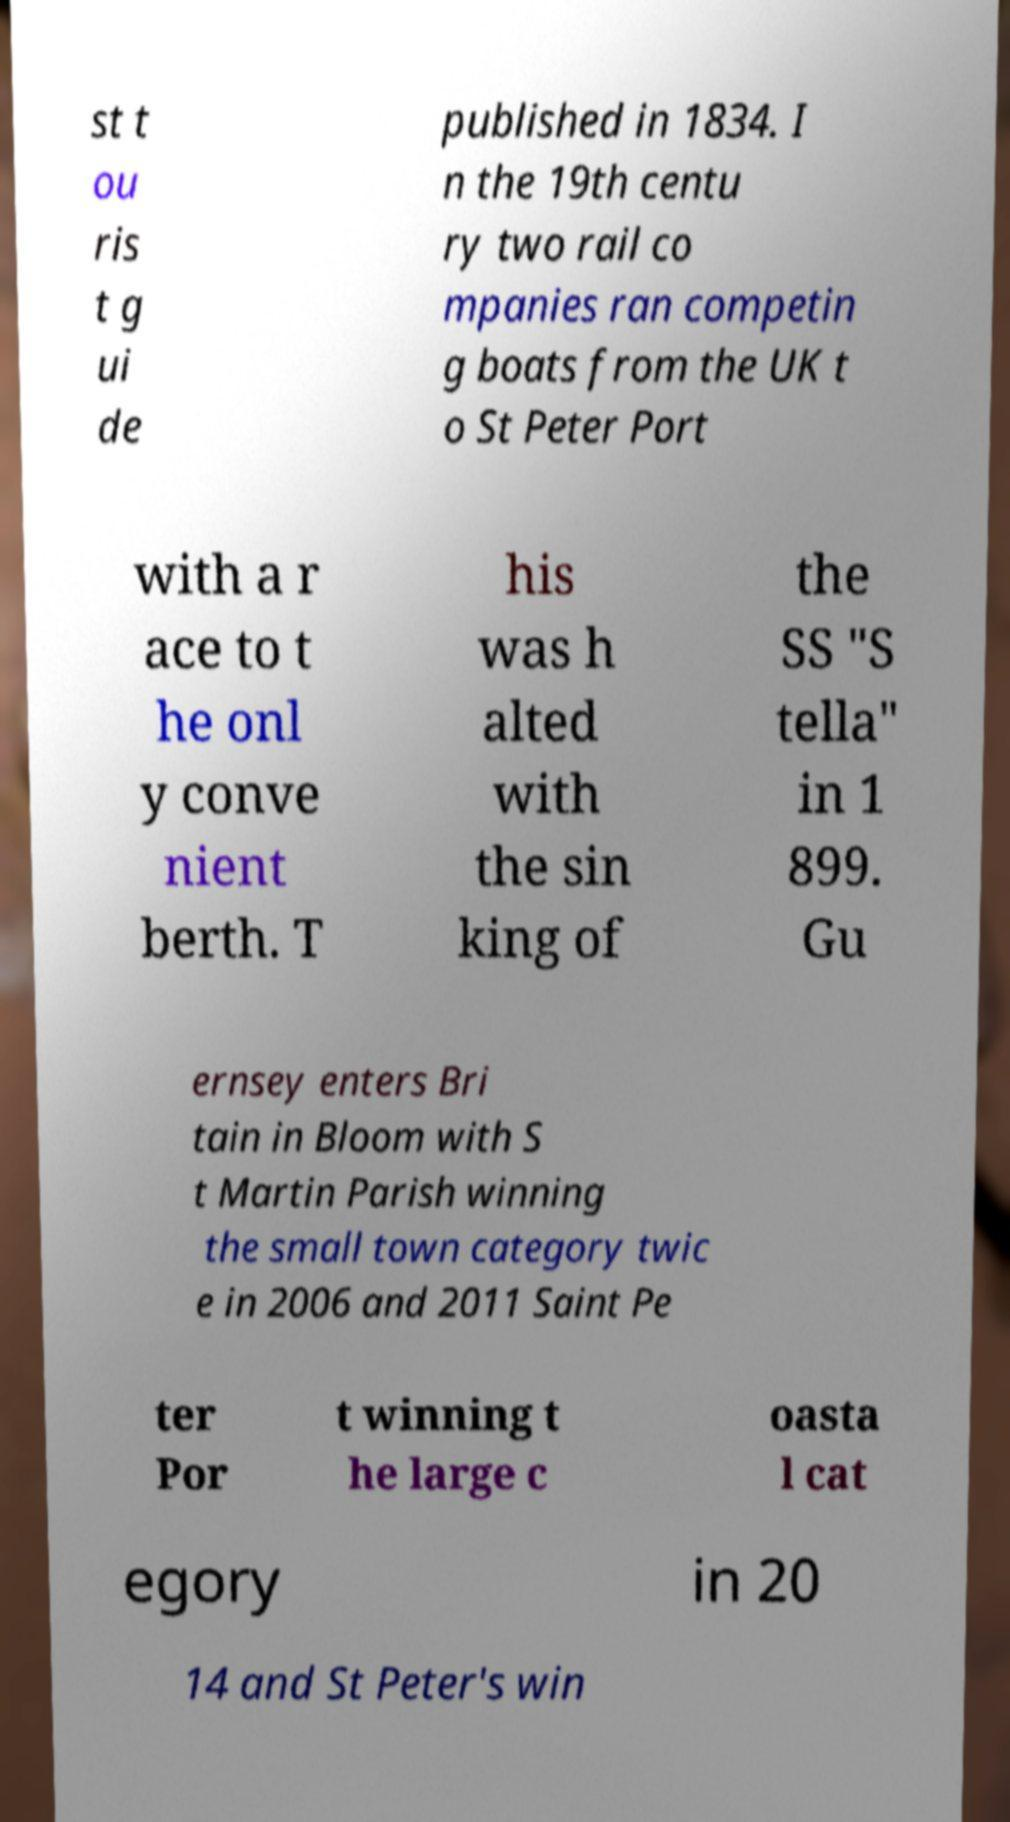I need the written content from this picture converted into text. Can you do that? st t ou ris t g ui de published in 1834. I n the 19th centu ry two rail co mpanies ran competin g boats from the UK t o St Peter Port with a r ace to t he onl y conve nient berth. T his was h alted with the sin king of the SS "S tella" in 1 899. Gu ernsey enters Bri tain in Bloom with S t Martin Parish winning the small town category twic e in 2006 and 2011 Saint Pe ter Por t winning t he large c oasta l cat egory in 20 14 and St Peter's win 